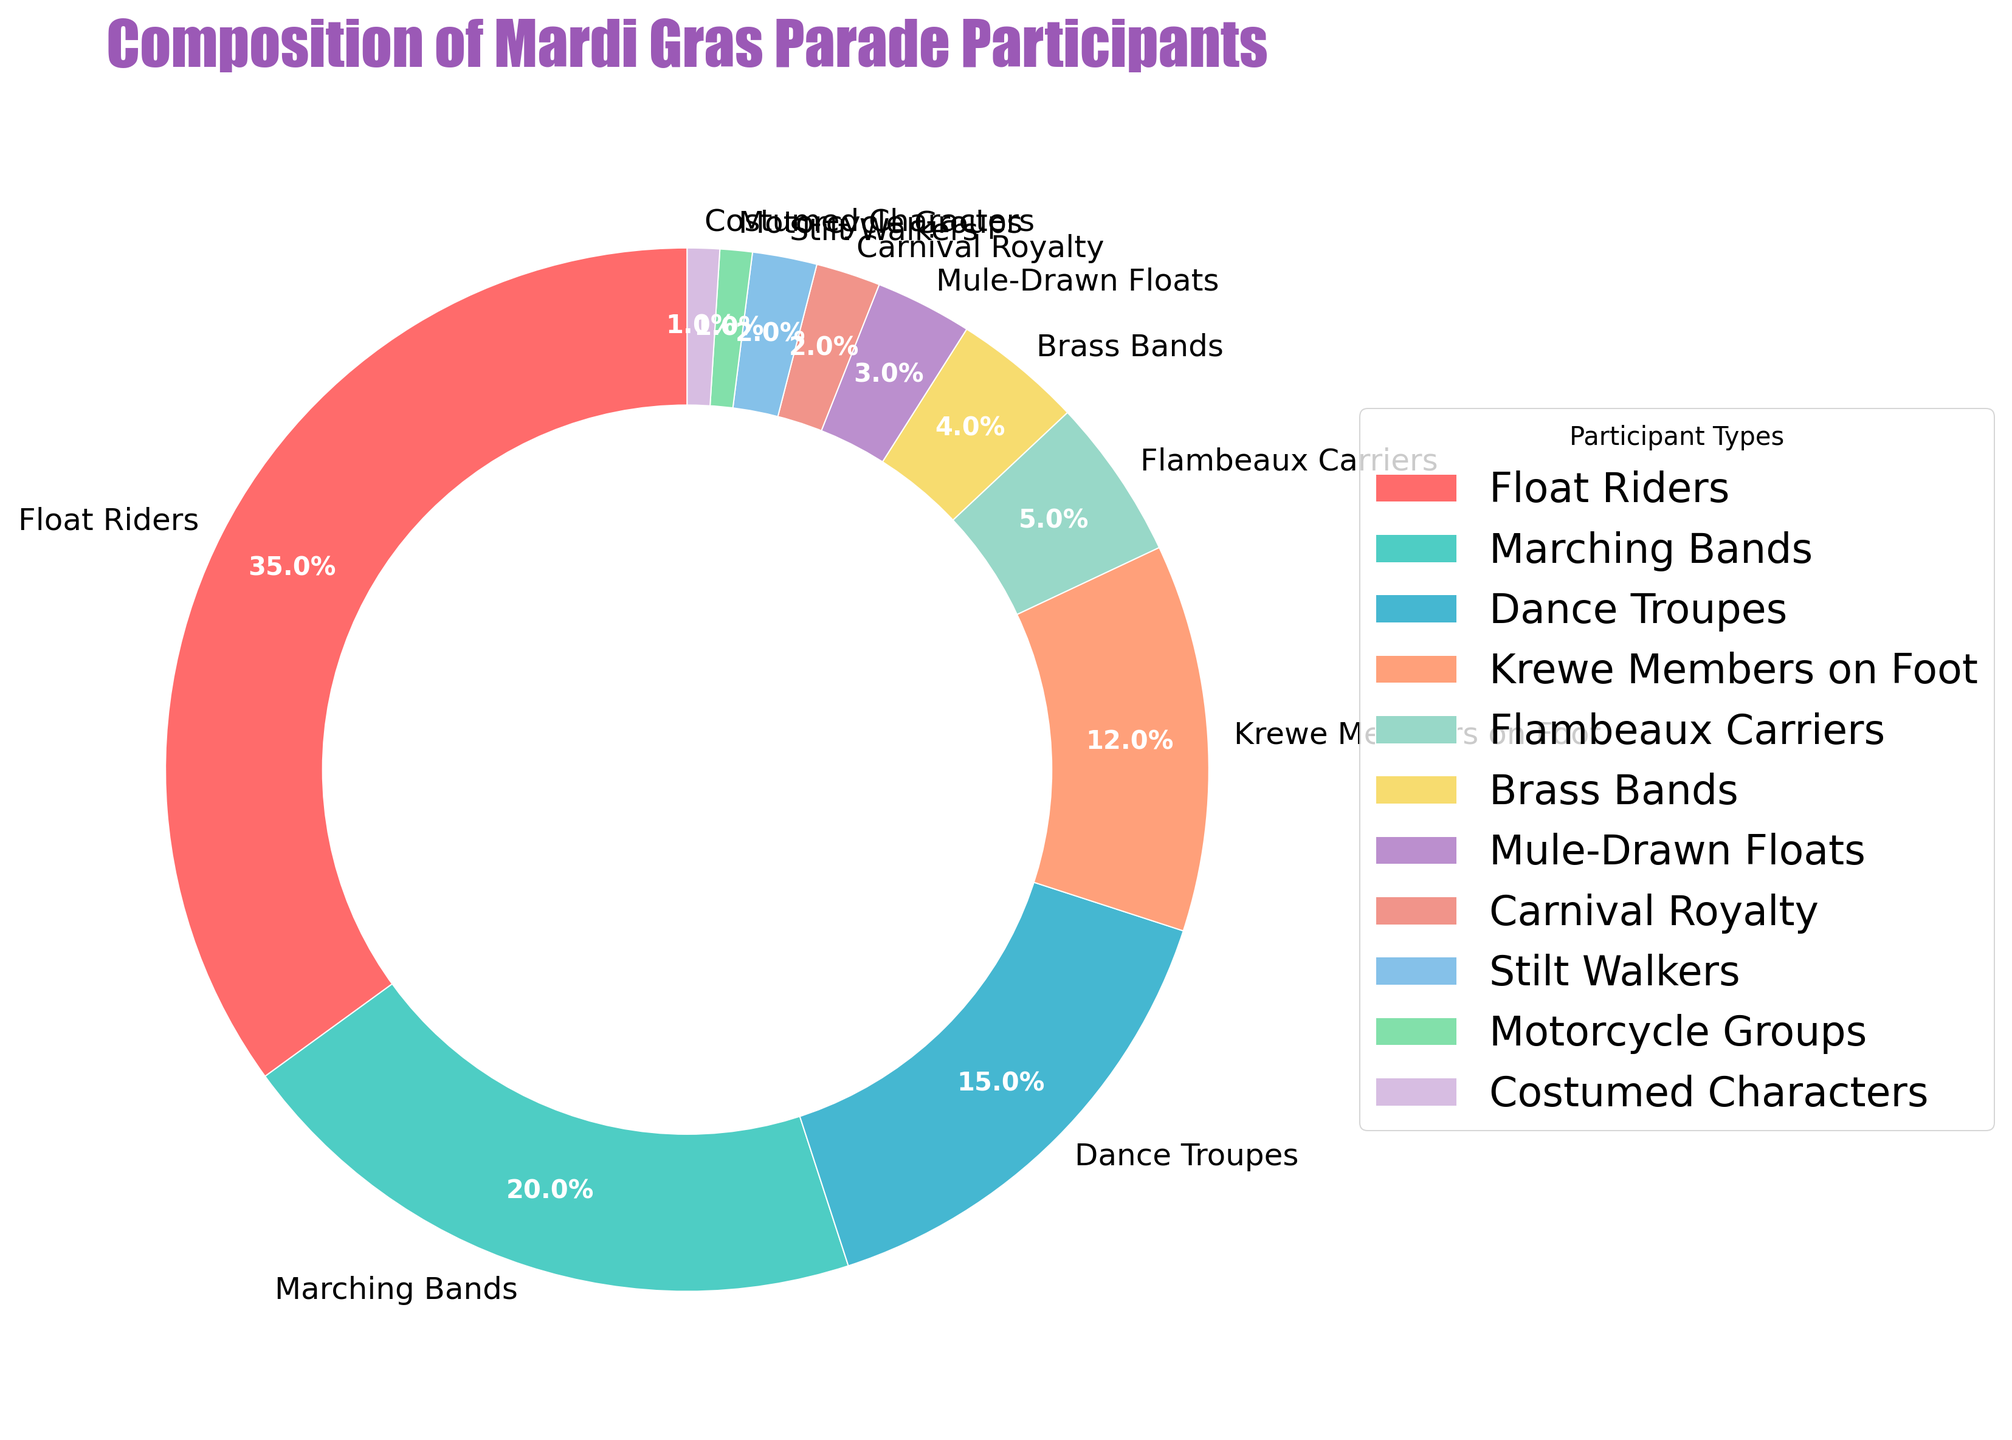Which participant type has the highest percentage in the Mardi Gras parade? The largest segment in the pie chart represents the Float Riders category, which visibly takes up the most space.
Answer: Float Riders What is the combined percentage of Dance Troupes and Marching Bands? By adding the percentages of Dance Troupes (15%) and Marching Bands (20%), we get the combined percentage: 15% + 20% = 35%.
Answer: 35% Which participant type occupies the smallest segment in the pie chart? The smallest segments are equally shared by Motorcycle Groups and Costumed Characters, each with 1% representation.
Answer: Motorcycle Groups and Costumed Characters How much larger is the percentage of Float Riders compared to Flambeaux Carriers? The percentage of Float Riders is 35%, while Flambeaux Carriers is 5%. The difference is calculated as 35% - 5% = 30%.
Answer: 30% What is the total percentage of participants made up by Krewe Members on Foot, Brass Bands, and Mule-Drawn Floats combined? Adding the percentages of Krewe Members on Foot (12%), Brass Bands (4%), and Mule-Drawn Floats (3%), we get the total percentage: 12% + 4% + 3% = 19%.
Answer: 19% Which participant type is represented by a green-colored segment? The green color segment corresponds to the Float Riders category, taking the largest area of the pie chart.
Answer: Float Riders Are there more Marching Bands or Dance Troupes in the parade? The pie chart shows Marching Bands at 20% and Dance Troupes at 15%, indicating that there are more Marching Bands.
Answer: Marching Bands 